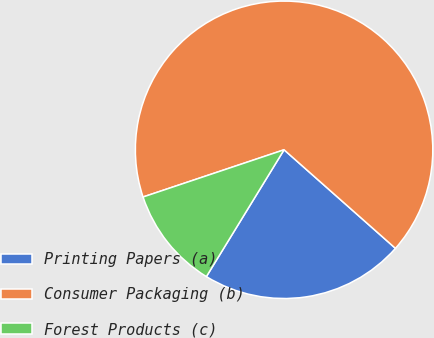Convert chart. <chart><loc_0><loc_0><loc_500><loc_500><pie_chart><fcel>Printing Papers (a)<fcel>Consumer Packaging (b)<fcel>Forest Products (c)<nl><fcel>22.22%<fcel>66.67%<fcel>11.11%<nl></chart> 